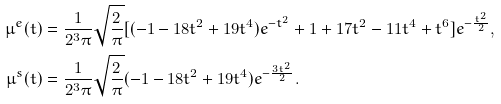Convert formula to latex. <formula><loc_0><loc_0><loc_500><loc_500>\mu ^ { e } ( t ) & = \frac { 1 } { 2 ^ { 3 } \pi } \sqrt { \frac { 2 } { \pi } } [ ( - 1 - 1 8 t ^ { 2 } + 1 9 t ^ { 4 } ) e ^ { - t ^ { 2 } } + 1 + 1 7 t ^ { 2 } - 1 1 t ^ { 4 } + t ^ { 6 } ] e ^ { - \frac { t ^ { 2 } } { 2 } } , \\ \mu ^ { s } ( t ) & = \frac { 1 } { 2 ^ { 3 } \pi } \sqrt { \frac { 2 } { \pi } } ( - 1 - 1 8 t ^ { 2 } + 1 9 t ^ { 4 } ) e ^ { - \frac { 3 t ^ { 2 } } { 2 } } .</formula> 